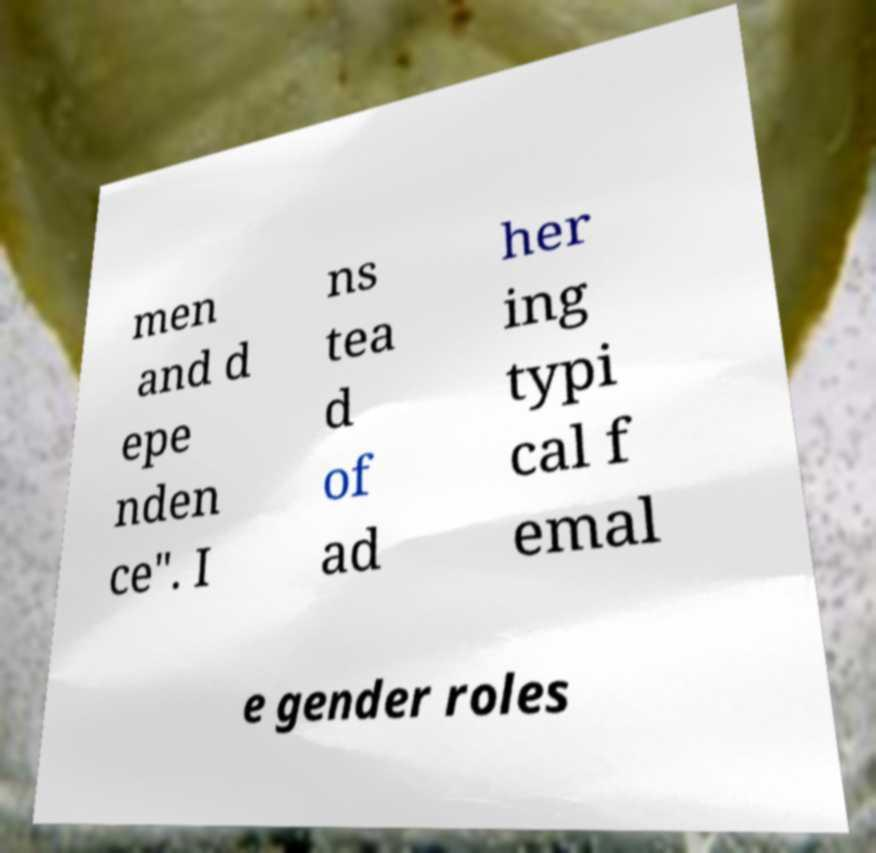Could you extract and type out the text from this image? men and d epe nden ce". I ns tea d of ad her ing typi cal f emal e gender roles 